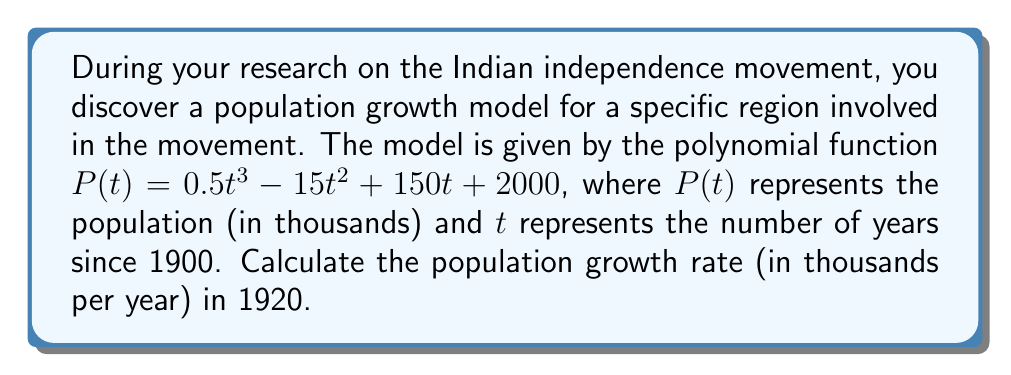What is the answer to this math problem? To find the population growth rate in 1920, we need to follow these steps:

1) The growth rate at any point is given by the derivative of the population function.

2) First, let's find the derivative of $P(t)$:
   $$P'(t) = 1.5t^2 - 30t + 150$$

3) We need to evaluate this at $t = 20$, since 1920 is 20 years after 1900:
   $$P'(20) = 1.5(20)^2 - 30(20) + 150$$

4) Let's calculate this step-by-step:
   $$P'(20) = 1.5(400) - 600 + 150$$
   $$P'(20) = 600 - 600 + 150$$
   $$P'(20) = 150$$

5) Therefore, the population growth rate in 1920 was 150 thousand people per year.
Answer: 150 